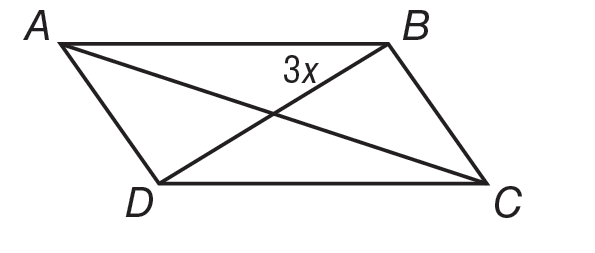Answer the mathemtical geometry problem and directly provide the correct option letter.
Question: Quadrilateral A B C D is shown. A C is 40 and B D is \frac { 3 } { 5 } A C. B D bisects A C. For what value of x is A B C D a parallelogram.
Choices: A: 0.6 B: 2.4 C: 4 D: 40 C 